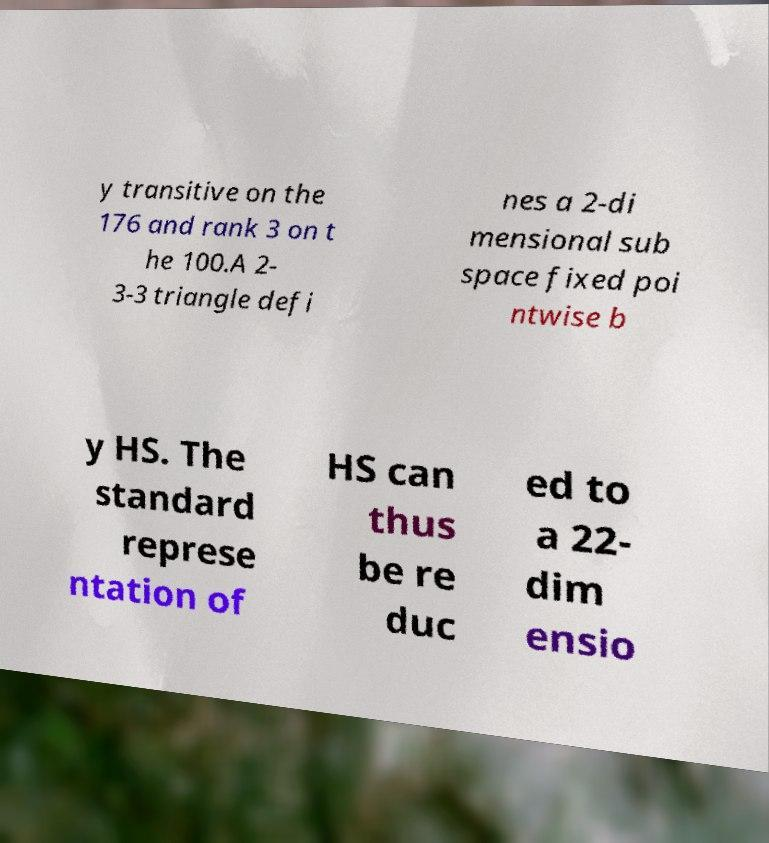What messages or text are displayed in this image? I need them in a readable, typed format. y transitive on the 176 and rank 3 on t he 100.A 2- 3-3 triangle defi nes a 2-di mensional sub space fixed poi ntwise b y HS. The standard represe ntation of HS can thus be re duc ed to a 22- dim ensio 